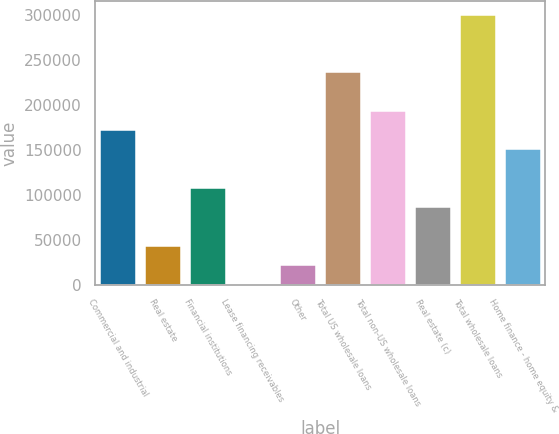Convert chart. <chart><loc_0><loc_0><loc_500><loc_500><bar_chart><fcel>Commercial and industrial<fcel>Real estate<fcel>Financial institutions<fcel>Lease financing receivables<fcel>Other<fcel>Total US wholesale loans<fcel>Total non-US wholesale loans<fcel>Real estate (c)<fcel>Total wholesale loans<fcel>Home finance - home equity &<nl><fcel>171934<fcel>43438<fcel>107686<fcel>606<fcel>22022<fcel>236182<fcel>193350<fcel>86270<fcel>300430<fcel>150518<nl></chart> 